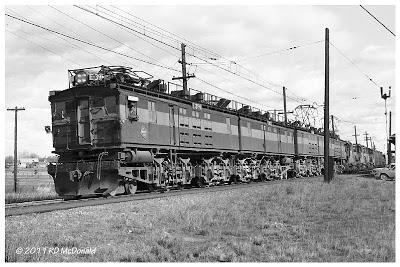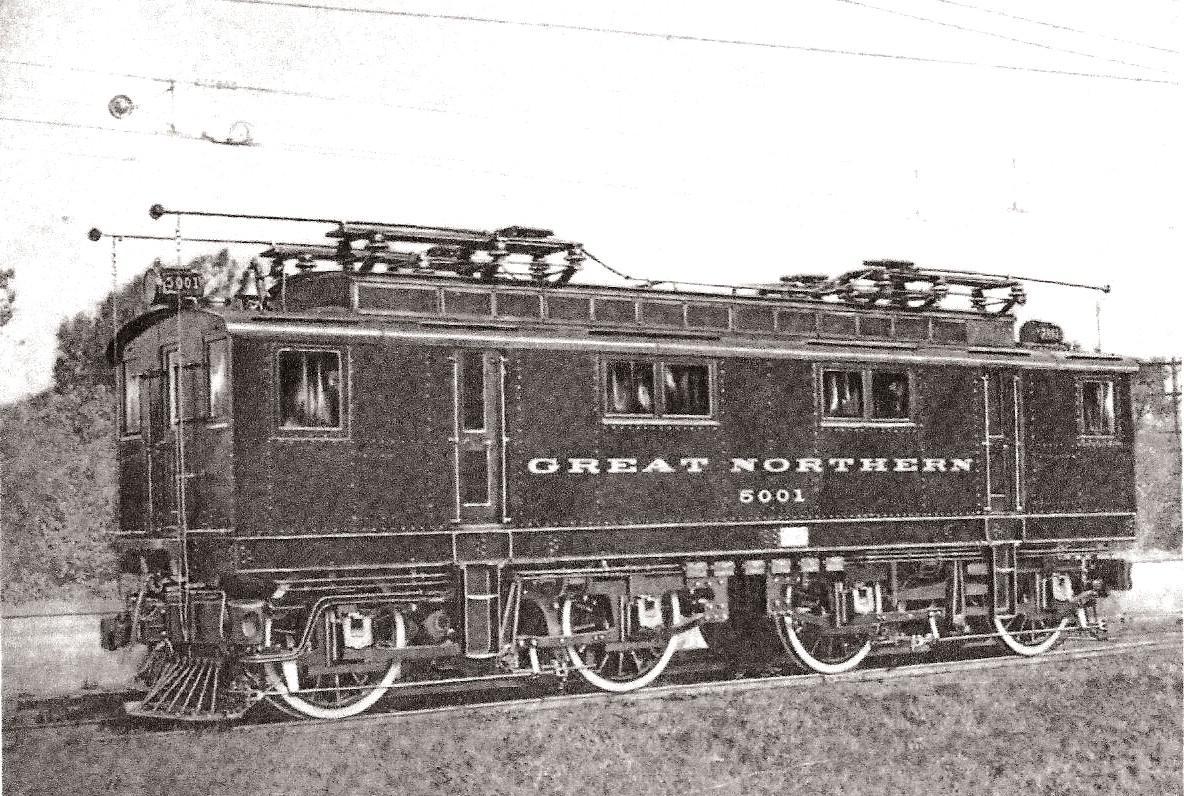The first image is the image on the left, the second image is the image on the right. Examine the images to the left and right. Is the description "Two trains are both heading towards the left direction." accurate? Answer yes or no. Yes. The first image is the image on the left, the second image is the image on the right. For the images shown, is this caption "The visible end of the train in the right image has a flat front above a cattle guard." true? Answer yes or no. Yes. 